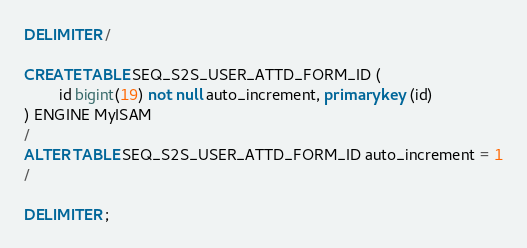<code> <loc_0><loc_0><loc_500><loc_500><_SQL_>DELIMITER /

CREATE TABLE SEQ_S2S_USER_ATTD_FORM_ID (
		id bigint(19) not null auto_increment, primary key (id)
) ENGINE MyISAM
/
ALTER TABLE SEQ_S2S_USER_ATTD_FORM_ID auto_increment = 1
/

DELIMITER ;
</code> 